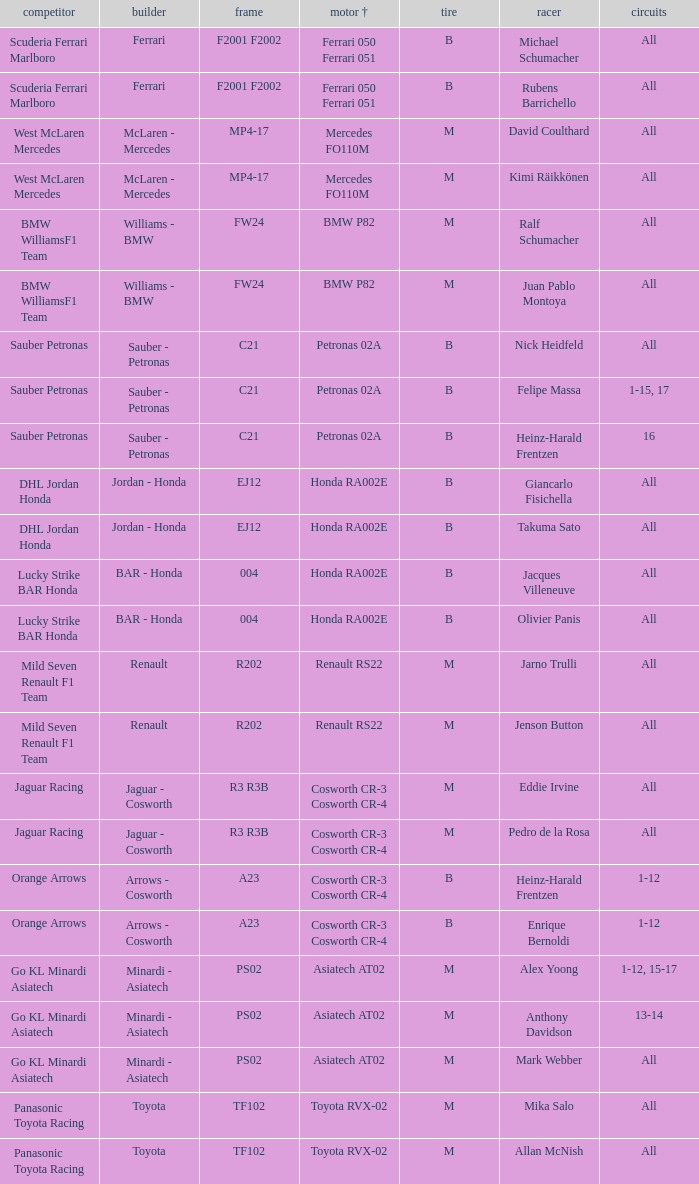When using a mercedes fo110m engine, what are the rounds? All, All. 